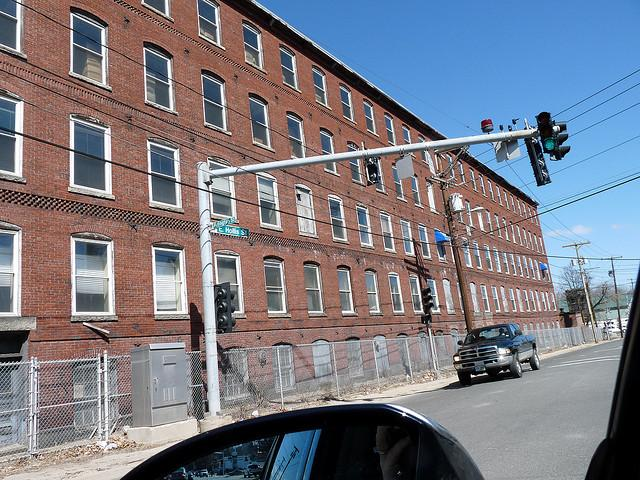What should the vehicle showing the side mirror do in this situation? Please explain your reasoning. go. The green light tells the driver to continue. 